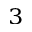Convert formula to latex. <formula><loc_0><loc_0><loc_500><loc_500>^ { 3 }</formula> 